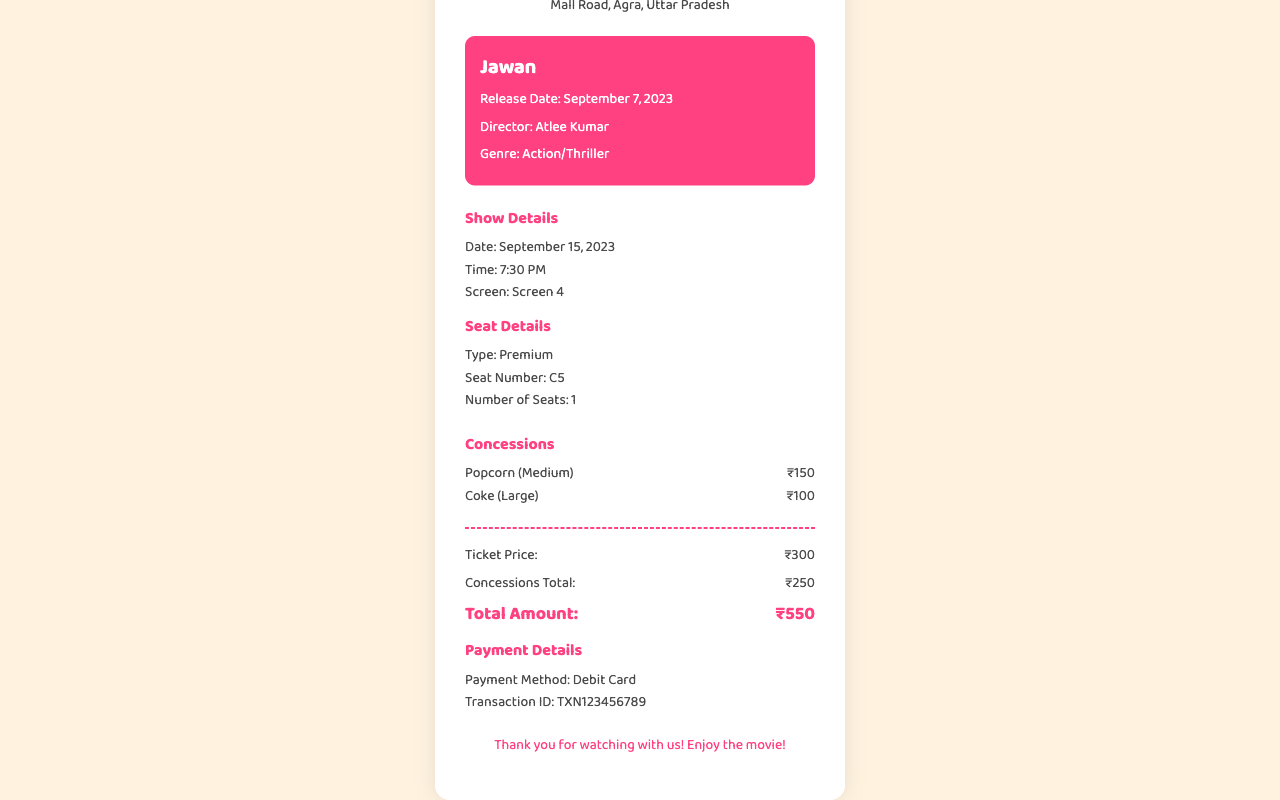What is the movie title? The movie title is prominently displayed in the movie info section of the receipt.
Answer: Jawan When was the show date? The show date is indicated under the show details section.
Answer: September 15, 2023 What is the seat number? The seat number is specified in the seat details section of the receipt.
Answer: C5 How much did the popcorn cost? The cost of popcorn is listed in the concessions section.
Answer: ₹150 What is the total amount? The total amount is calculated in the total section of the receipt.
Answer: ₹550 How many seats were booked? The number of seats is provided in the seat details section.
Answer: 1 Who is the director of the film? The director's name is mentioned in the movie info section of the receipt.
Answer: Atlee Kumar What payment method was used? The payment method is located in the payment details section of the receipt.
Answer: Debit Card Which screen was the movie shown on? The screen information is detailed in the show details section.
Answer: Screen 4 